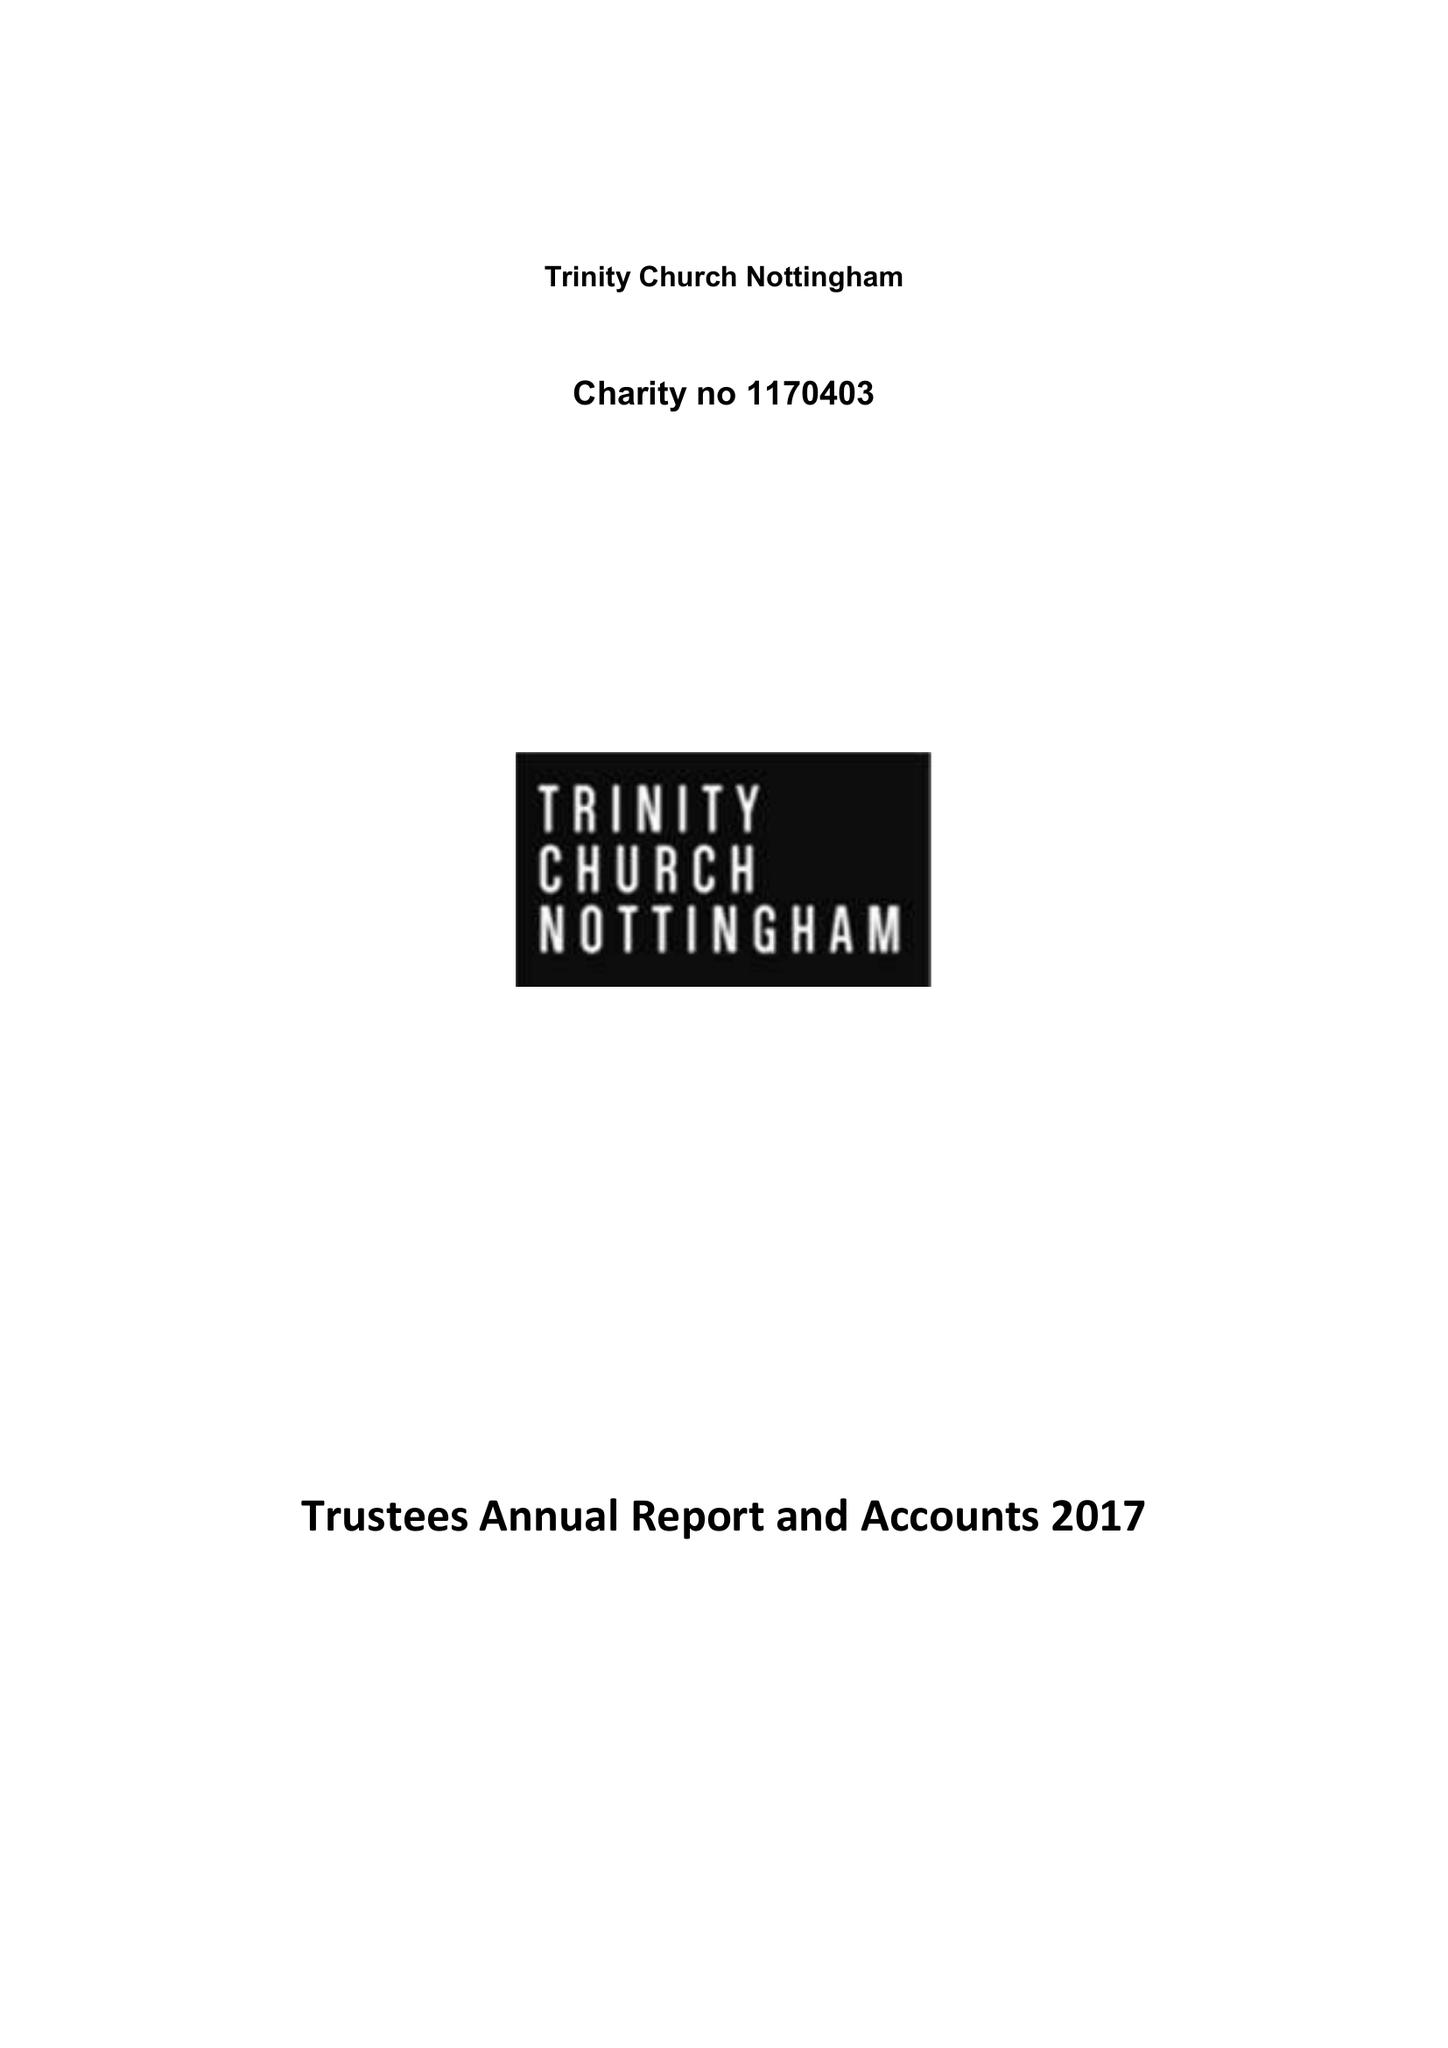What is the value for the report_date?
Answer the question using a single word or phrase. 2018-04-05 